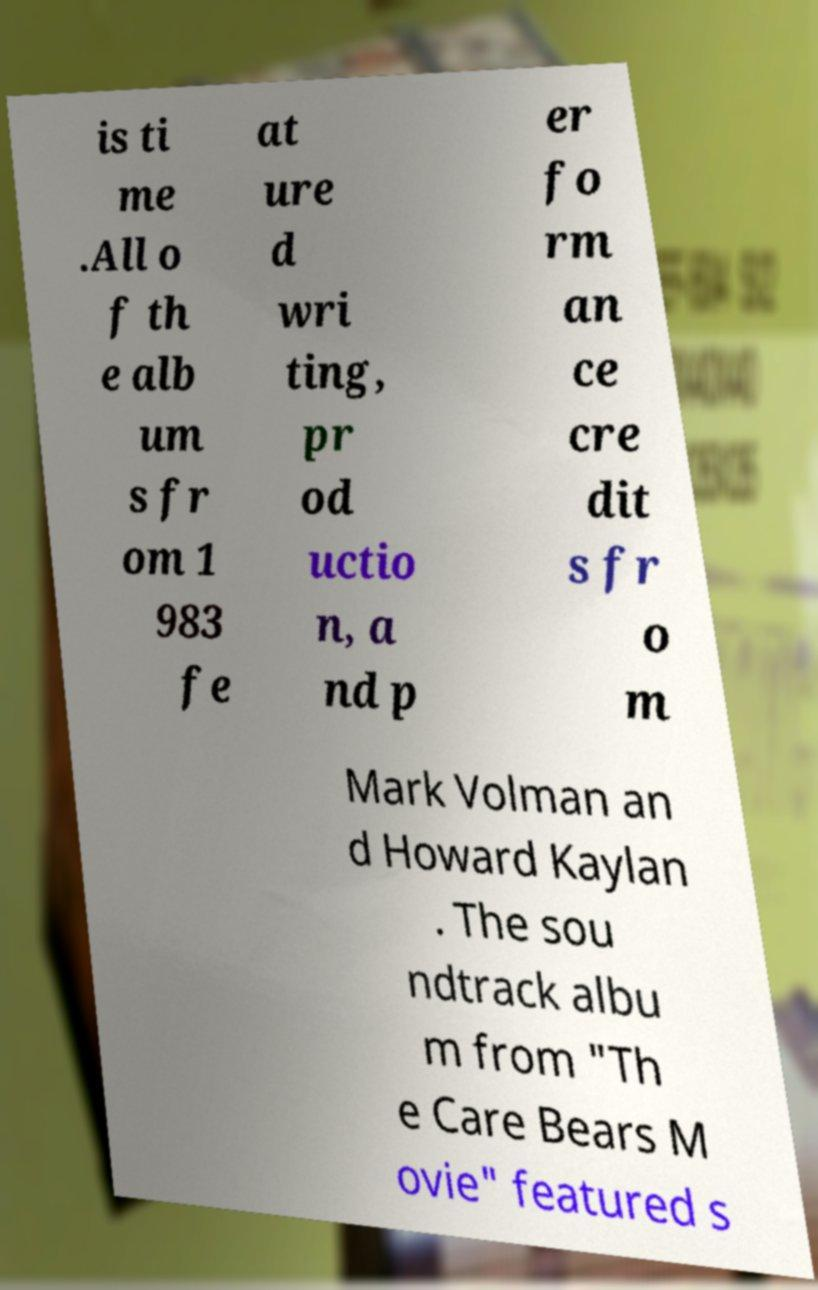What messages or text are displayed in this image? I need them in a readable, typed format. is ti me .All o f th e alb um s fr om 1 983 fe at ure d wri ting, pr od uctio n, a nd p er fo rm an ce cre dit s fr o m Mark Volman an d Howard Kaylan . The sou ndtrack albu m from "Th e Care Bears M ovie" featured s 